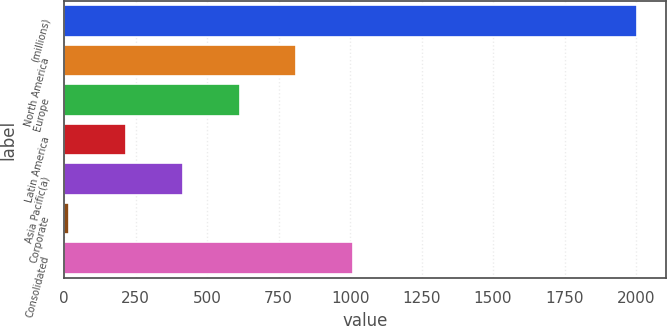Convert chart to OTSL. <chart><loc_0><loc_0><loc_500><loc_500><bar_chart><fcel>(millions)<fcel>North America<fcel>Europe<fcel>Latin America<fcel>Asia Pacific(a)<fcel>Corporate<fcel>Consolidated<nl><fcel>2005<fcel>812.44<fcel>613.68<fcel>216.16<fcel>414.92<fcel>17.4<fcel>1011.2<nl></chart> 